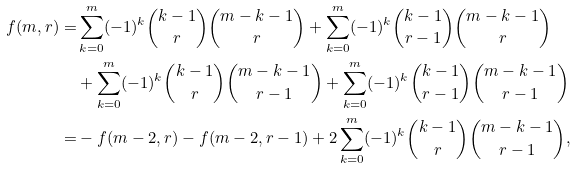Convert formula to latex. <formula><loc_0><loc_0><loc_500><loc_500>f ( m , r ) = & \sum _ { k = 0 } ^ { m } ( - 1 ) ^ { k } \binom { k - 1 } { r } \binom { m - k - 1 } { r } + \sum _ { k = 0 } ^ { m } ( - 1 ) ^ { k } \binom { k - 1 } { r - 1 } \binom { m - k - 1 } { r } \\ & + \sum _ { k = 0 } ^ { m } ( - 1 ) ^ { k } \binom { k - 1 } { r } \binom { m - k - 1 } { r - 1 } + \sum _ { k = 0 } ^ { m } ( - 1 ) ^ { k } \binom { k - 1 } { r - 1 } \binom { m - k - 1 } { r - 1 } \\ = & - f ( m - 2 , r ) - f ( m - 2 , r - 1 ) + 2 \sum _ { k = 0 } ^ { m } ( - 1 ) ^ { k } \binom { k - 1 } { r } \binom { m - k - 1 } { r - 1 } ,</formula> 